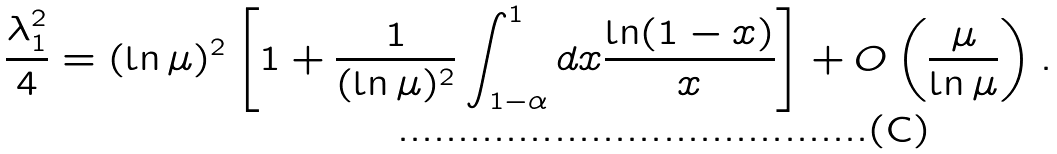<formula> <loc_0><loc_0><loc_500><loc_500>\frac { \lambda _ { 1 } ^ { 2 } } { 4 } = ( \ln \mu ) ^ { 2 } \left [ 1 + \frac { 1 } { ( \ln \mu ) ^ { 2 } } \int _ { 1 - \alpha } ^ { 1 } d x \frac { \ln ( 1 - x ) } { x } \right ] + O \left ( \frac { \mu } { \ln \mu } \right ) .</formula> 